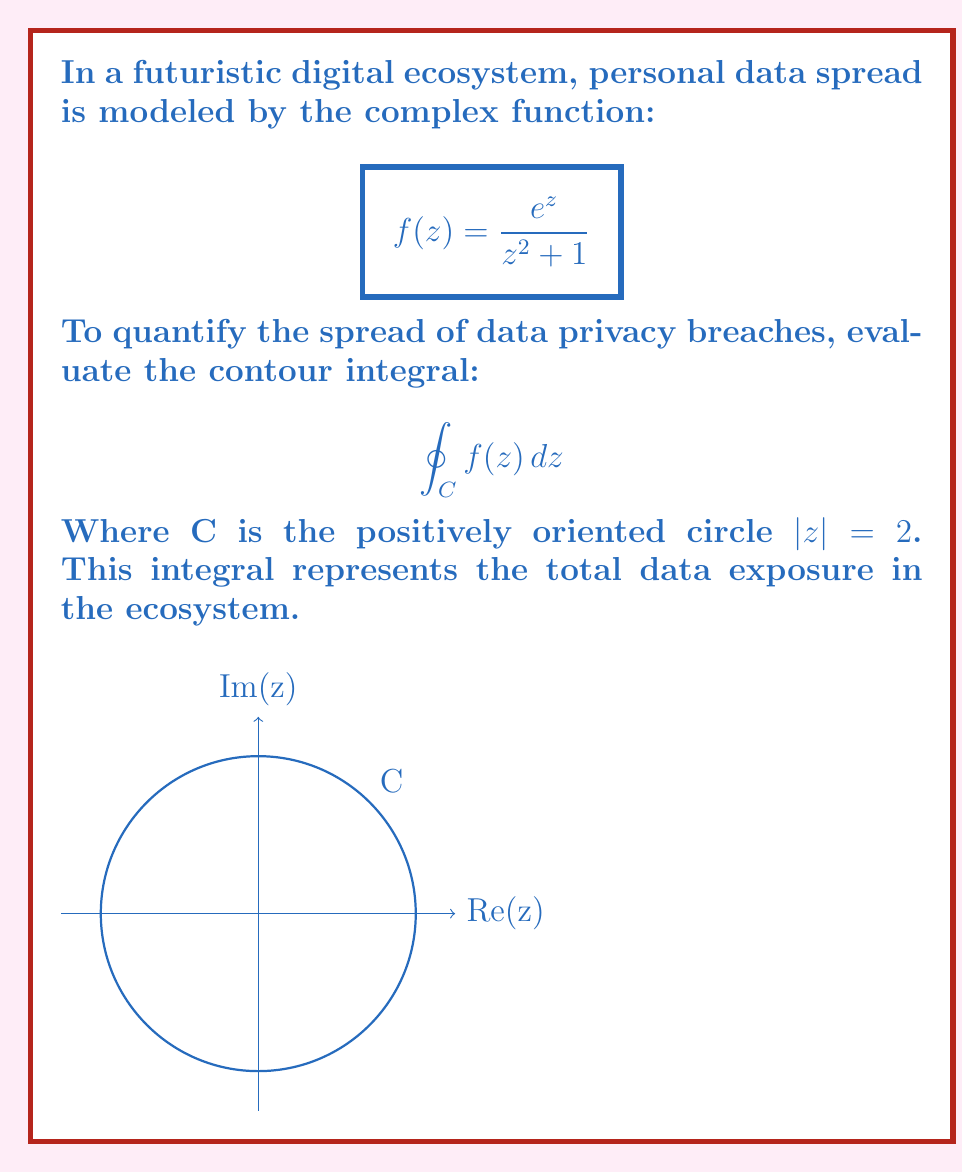Provide a solution to this math problem. To evaluate this contour integral, we'll use the Residue Theorem:

$$\oint_C f(z) dz = 2\pi i \sum_{k=1}^n \text{Res}(f, a_k)$$

Where $a_k$ are the poles of $f(z)$ inside C.

Step 1: Find the poles of $f(z)$
The poles are where $z^2 + 1 = 0$, i.e., $z = \pm i$. Only $z = i$ is inside C.

Step 2: Determine the order of the pole
It's a simple pole (order 1) because $(z^2 + 1)$ appears to the first power in the denominator.

Step 3: Calculate the residue at $z = i$
For a simple pole, we can use the formula:
$$\text{Res}(f, i) = \lim_{z \to i} (z-i)f(z) = \lim_{z \to i} \frac{(z-i)e^z}{z^2 + 1}$$

Applying L'Hôpital's rule:
$$\text{Res}(f, i) = \lim_{z \to i} \frac{e^z + (z-i)e^z}{2z} = \frac{e^i}{2i}$$

Step 4: Apply the Residue Theorem
$$\oint_C f(z) dz = 2\pi i \cdot \frac{e^i}{2i} = \pi e^i$$

This complex number represents the magnitude and phase of data exposure.
Answer: $\pi e^i$ 